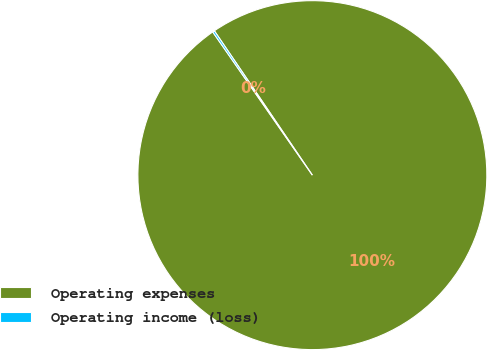<chart> <loc_0><loc_0><loc_500><loc_500><pie_chart><fcel>Operating expenses<fcel>Operating income (loss)<nl><fcel>99.82%<fcel>0.18%<nl></chart> 